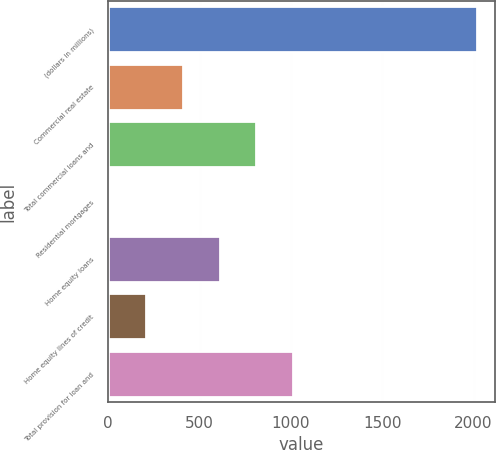Convert chart. <chart><loc_0><loc_0><loc_500><loc_500><bar_chart><fcel>(dollars in millions)<fcel>Commercial real estate<fcel>Total commercial loans and<fcel>Residential mortgages<fcel>Home equity loans<fcel>Home equity lines of credit<fcel>Total provision for loan and<nl><fcel>2016<fcel>409.6<fcel>811.2<fcel>8<fcel>610.4<fcel>208.8<fcel>1012<nl></chart> 